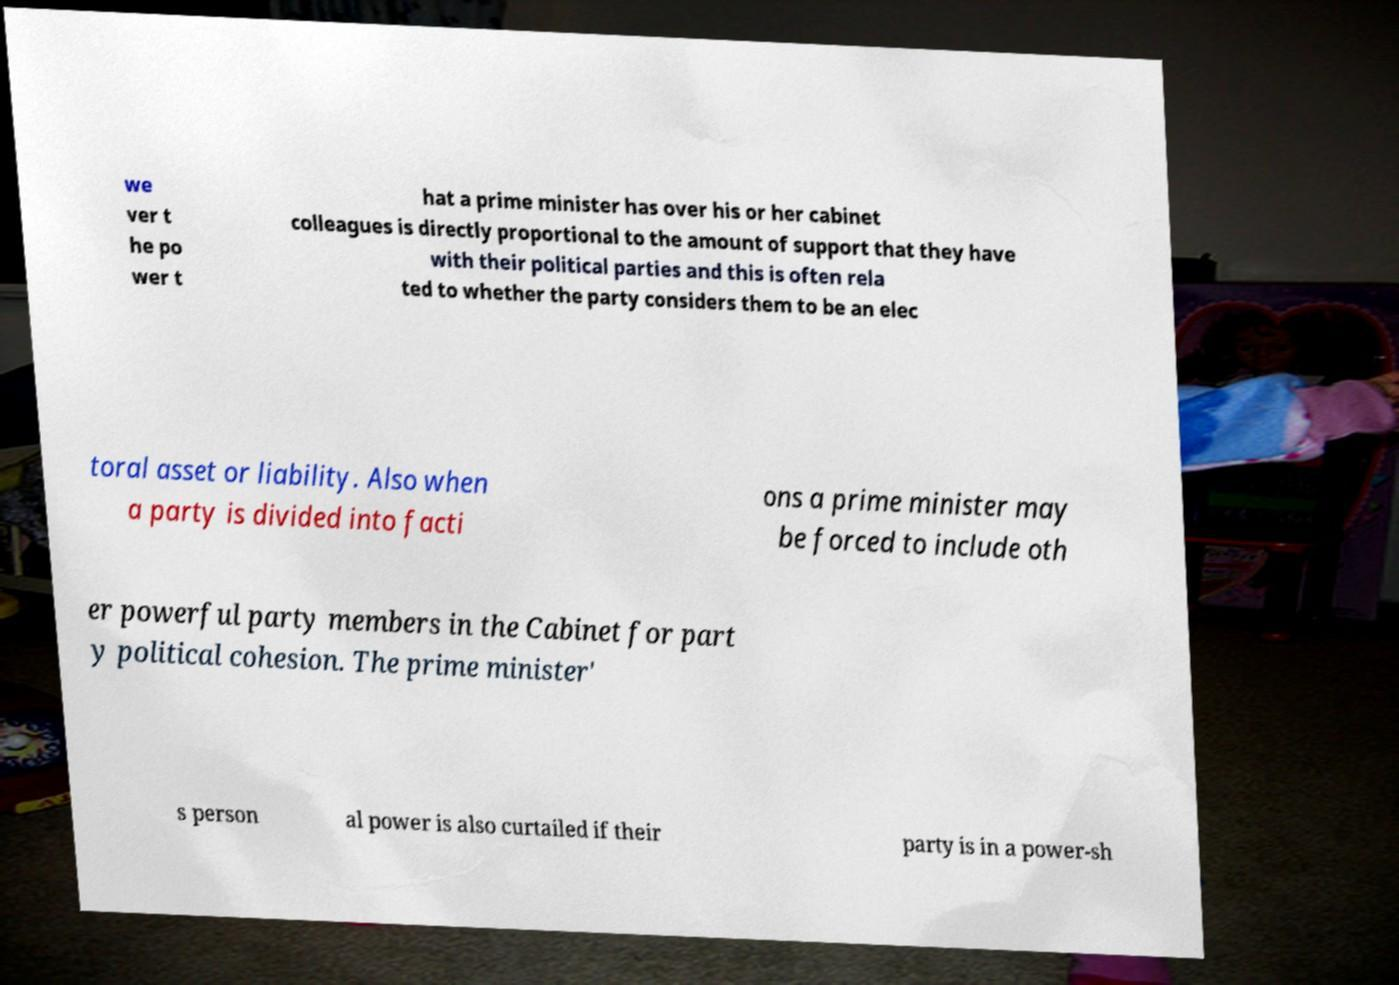Please identify and transcribe the text found in this image. we ver t he po wer t hat a prime minister has over his or her cabinet colleagues is directly proportional to the amount of support that they have with their political parties and this is often rela ted to whether the party considers them to be an elec toral asset or liability. Also when a party is divided into facti ons a prime minister may be forced to include oth er powerful party members in the Cabinet for part y political cohesion. The prime minister' s person al power is also curtailed if their party is in a power-sh 